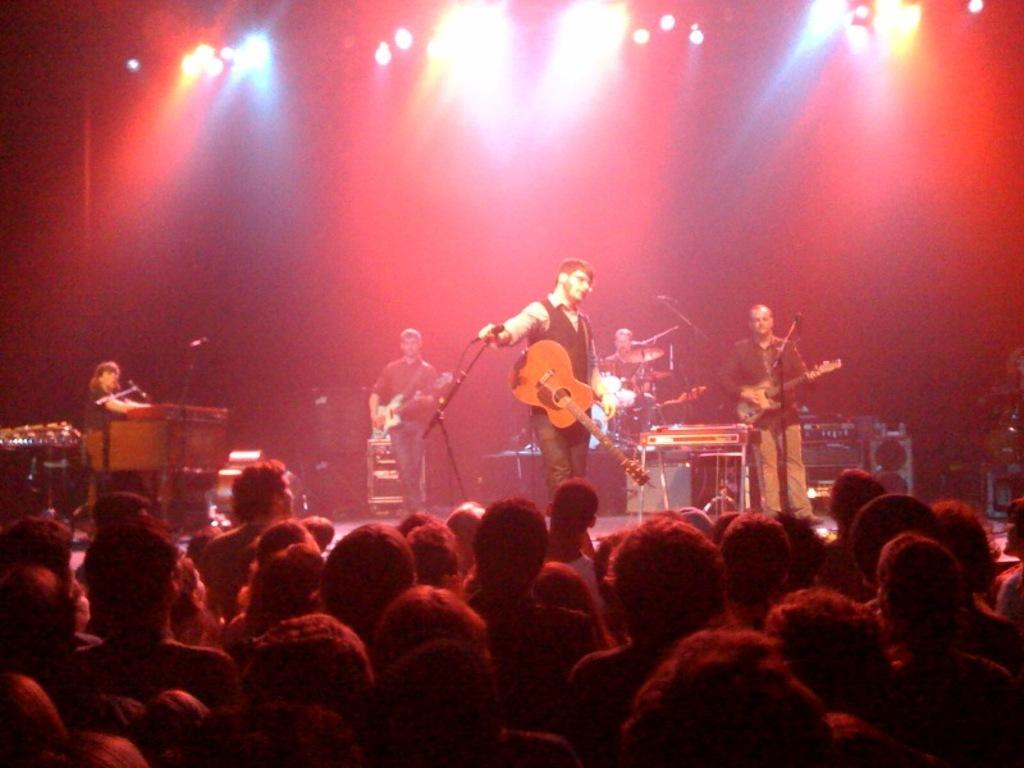What are the persons on the stage doing in the image? The persons on the stage are playing musical instruments. Can you describe the setting of the image? There are persons standing on the stage, and there is an audience visible in the image. What hobbies do the persons on the stage have outside of their musical performances? The image does not provide information about the persons' hobbies outside of their musical performances. 